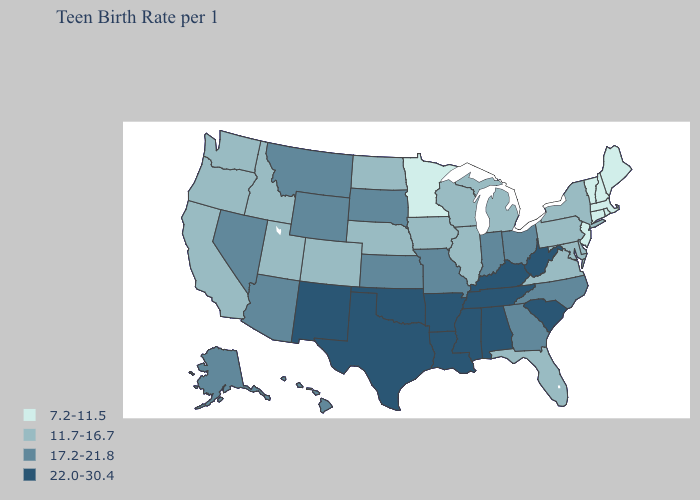Does Illinois have the highest value in the MidWest?
Short answer required. No. Among the states that border Alabama , does Tennessee have the highest value?
Answer briefly. Yes. What is the value of Alaska?
Answer briefly. 17.2-21.8. Name the states that have a value in the range 17.2-21.8?
Write a very short answer. Alaska, Arizona, Georgia, Hawaii, Indiana, Kansas, Missouri, Montana, Nevada, North Carolina, Ohio, South Dakota, Wyoming. Does Mississippi have the highest value in the USA?
Answer briefly. Yes. What is the lowest value in states that border Kansas?
Short answer required. 11.7-16.7. Does the first symbol in the legend represent the smallest category?
Give a very brief answer. Yes. Does the map have missing data?
Be succinct. No. Does Maine have the highest value in the USA?
Short answer required. No. Name the states that have a value in the range 7.2-11.5?
Be succinct. Connecticut, Maine, Massachusetts, Minnesota, New Hampshire, New Jersey, Rhode Island, Vermont. Does Montana have the same value as New York?
Write a very short answer. No. What is the value of Iowa?
Concise answer only. 11.7-16.7. Among the states that border Kansas , which have the highest value?
Keep it brief. Oklahoma. Name the states that have a value in the range 17.2-21.8?
Write a very short answer. Alaska, Arizona, Georgia, Hawaii, Indiana, Kansas, Missouri, Montana, Nevada, North Carolina, Ohio, South Dakota, Wyoming. Does Wyoming have a higher value than Louisiana?
Quick response, please. No. 